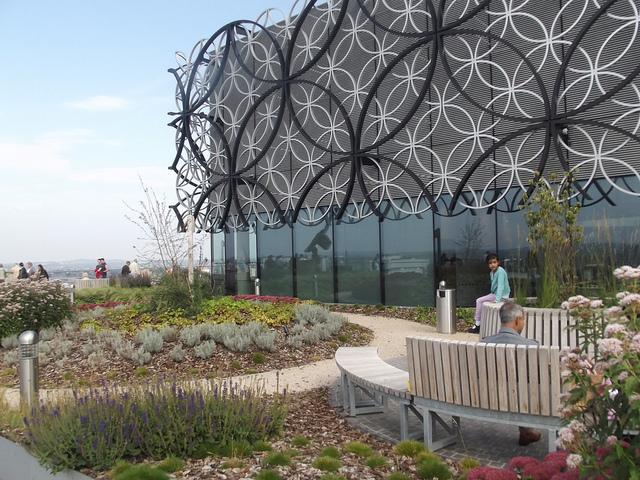What should be put in the hole near the nearby child? Please explain your reasoning. trash. It has the opening on the side so that rubbish can be dropped into it. 